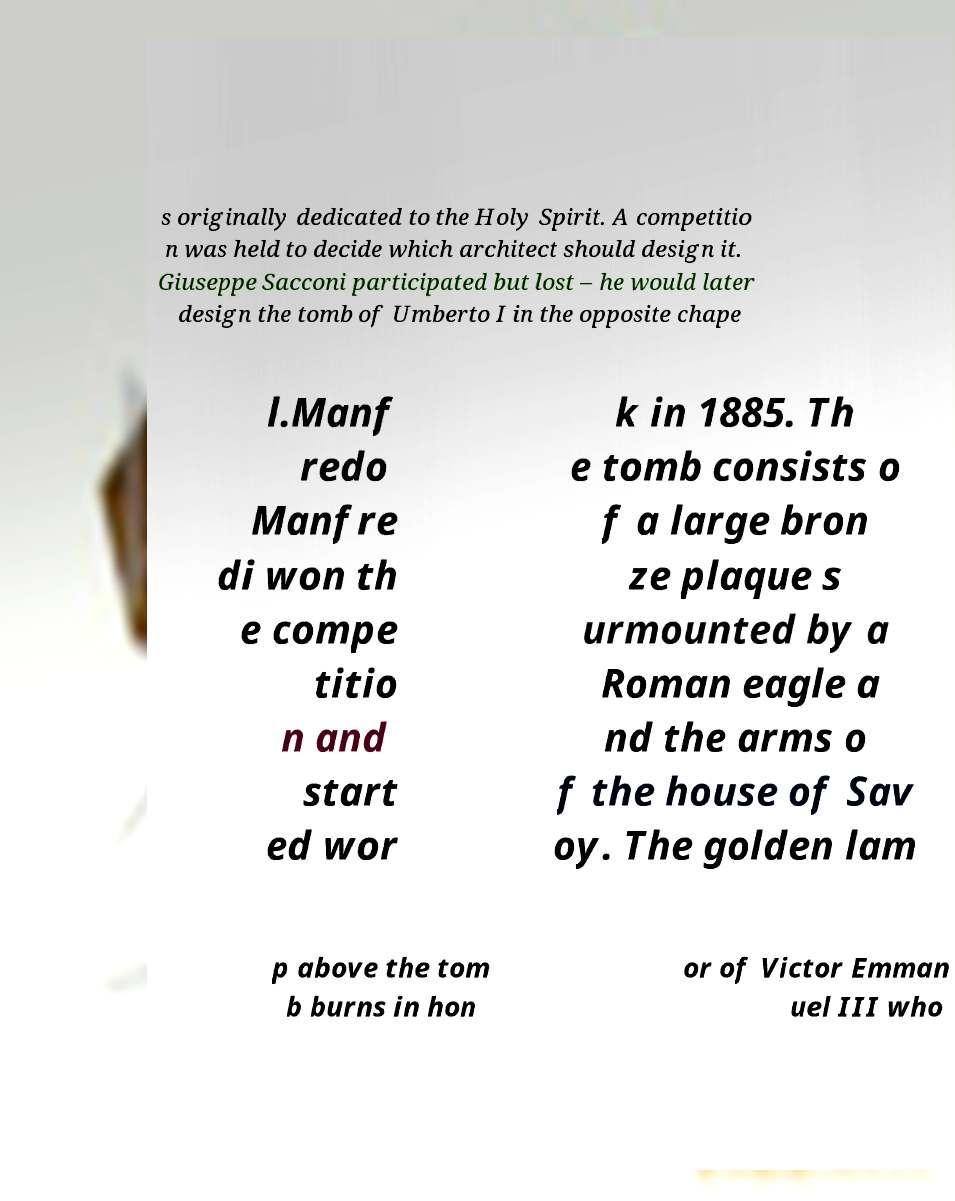I need the written content from this picture converted into text. Can you do that? s originally dedicated to the Holy Spirit. A competitio n was held to decide which architect should design it. Giuseppe Sacconi participated but lost – he would later design the tomb of Umberto I in the opposite chape l.Manf redo Manfre di won th e compe titio n and start ed wor k in 1885. Th e tomb consists o f a large bron ze plaque s urmounted by a Roman eagle a nd the arms o f the house of Sav oy. The golden lam p above the tom b burns in hon or of Victor Emman uel III who 